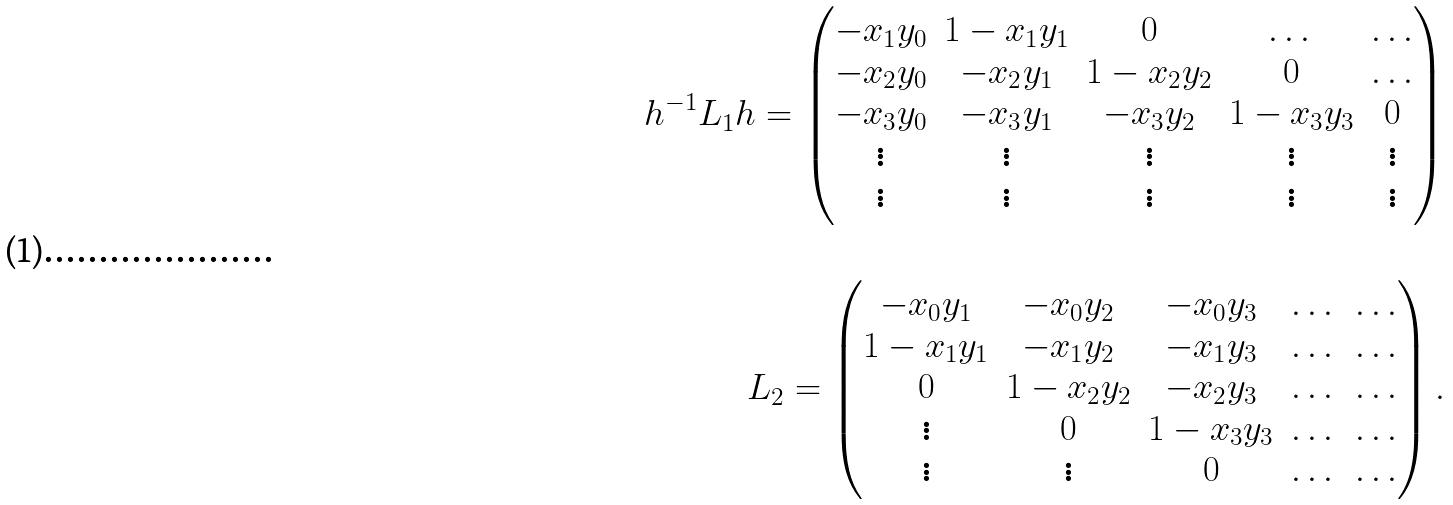Convert formula to latex. <formula><loc_0><loc_0><loc_500><loc_500>h ^ { - 1 } L _ { 1 } h = \begin{pmatrix} - x _ { 1 } y _ { 0 } & 1 - x _ { 1 } y _ { 1 } & 0 & \dots & \dots \\ - x _ { 2 } y _ { 0 } & - x _ { 2 } y _ { 1 } & 1 - x _ { 2 } y _ { 2 } & 0 & \dots \\ - x _ { 3 } y _ { 0 } & - x _ { 3 } y _ { 1 } & - x _ { 3 } y _ { 2 } & 1 - x _ { 3 } y _ { 3 } & 0 \\ \vdots & \vdots & \vdots & \vdots & \vdots \\ \vdots & \vdots & \vdots & \vdots & \vdots \end{pmatrix} \\ \\ L _ { 2 } = \begin{pmatrix} - x _ { 0 } y _ { 1 } & - x _ { 0 } y _ { 2 } & - x _ { 0 } y _ { 3 } & \dots & \dots \\ 1 - x _ { 1 } y _ { 1 } & - x _ { 1 } y _ { 2 } & - x _ { 1 } y _ { 3 } & \dots & \dots \\ 0 & 1 - x _ { 2 } y _ { 2 } & - x _ { 2 } y _ { 3 } & \dots & \dots \\ \vdots & 0 & 1 - x _ { 3 } y _ { 3 } & \dots & \dots \\ \vdots & \vdots & 0 & \dots & \dots \end{pmatrix} .</formula> 